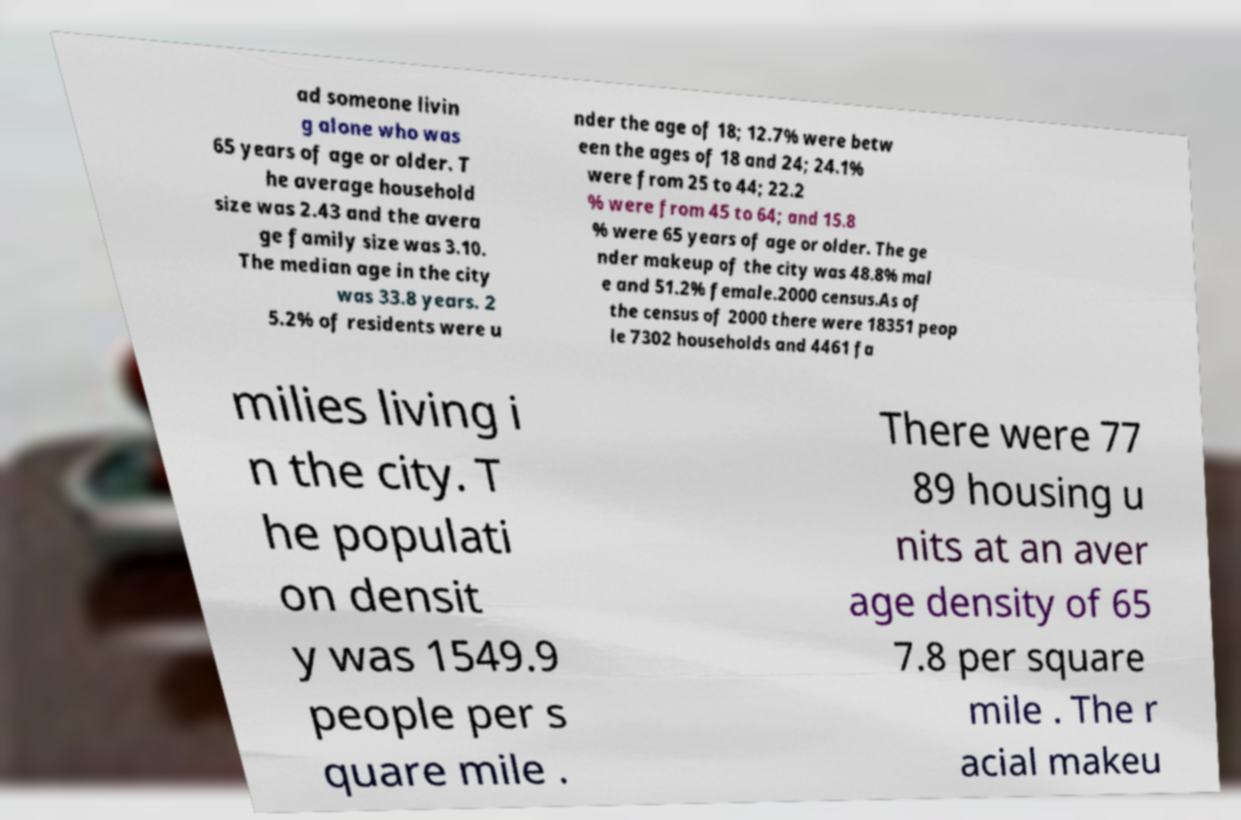I need the written content from this picture converted into text. Can you do that? ad someone livin g alone who was 65 years of age or older. T he average household size was 2.43 and the avera ge family size was 3.10. The median age in the city was 33.8 years. 2 5.2% of residents were u nder the age of 18; 12.7% were betw een the ages of 18 and 24; 24.1% were from 25 to 44; 22.2 % were from 45 to 64; and 15.8 % were 65 years of age or older. The ge nder makeup of the city was 48.8% mal e and 51.2% female.2000 census.As of the census of 2000 there were 18351 peop le 7302 households and 4461 fa milies living i n the city. T he populati on densit y was 1549.9 people per s quare mile . There were 77 89 housing u nits at an aver age density of 65 7.8 per square mile . The r acial makeu 